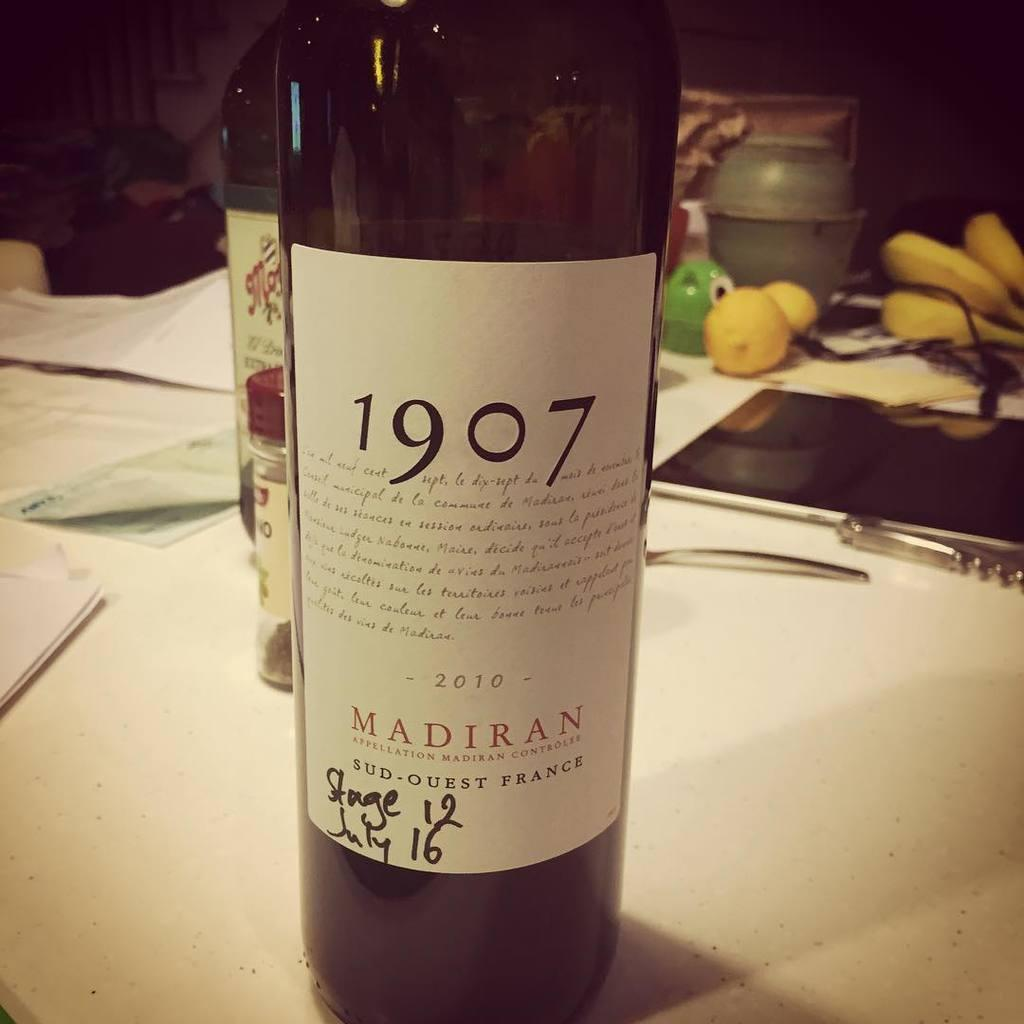Provide a one-sentence caption for the provided image. A big wine bottle that has the numbers 1907 on it. 